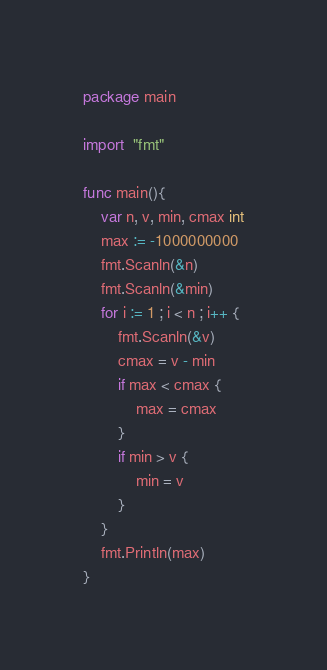Convert code to text. <code><loc_0><loc_0><loc_500><loc_500><_Go_>package main

import  "fmt"

func main(){
    var n, v, min, cmax int
    max := -1000000000
    fmt.Scanln(&n)
    fmt.Scanln(&min)
    for i := 1 ; i < n ; i++ {
        fmt.Scanln(&v)
        cmax = v - min
        if max < cmax {
            max = cmax
        }
        if min > v {
            min = v
        }
    }
    fmt.Println(max)
}
</code> 